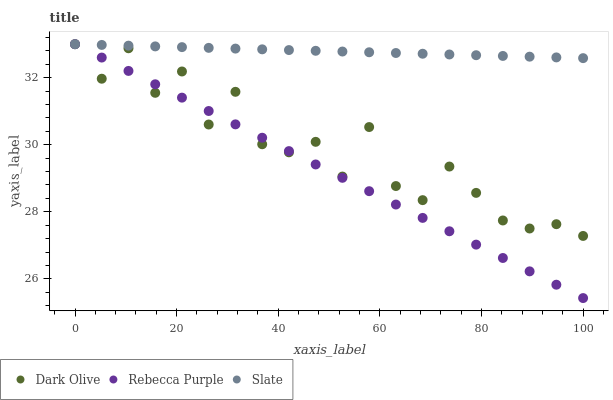Does Rebecca Purple have the minimum area under the curve?
Answer yes or no. Yes. Does Slate have the maximum area under the curve?
Answer yes or no. Yes. Does Dark Olive have the minimum area under the curve?
Answer yes or no. No. Does Dark Olive have the maximum area under the curve?
Answer yes or no. No. Is Rebecca Purple the smoothest?
Answer yes or no. Yes. Is Dark Olive the roughest?
Answer yes or no. Yes. Is Dark Olive the smoothest?
Answer yes or no. No. Is Rebecca Purple the roughest?
Answer yes or no. No. Does Rebecca Purple have the lowest value?
Answer yes or no. Yes. Does Dark Olive have the lowest value?
Answer yes or no. No. Does Rebecca Purple have the highest value?
Answer yes or no. Yes. Does Slate intersect Dark Olive?
Answer yes or no. Yes. Is Slate less than Dark Olive?
Answer yes or no. No. Is Slate greater than Dark Olive?
Answer yes or no. No. 